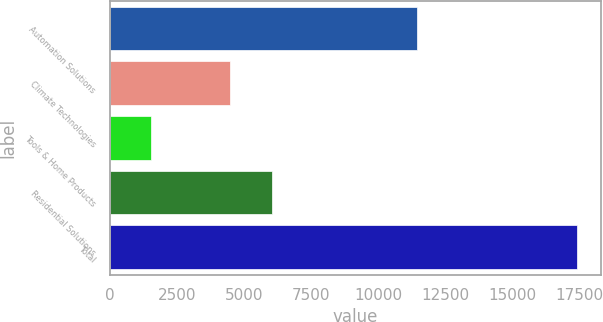<chart> <loc_0><loc_0><loc_500><loc_500><bar_chart><fcel>Automation Solutions<fcel>Climate Technologies<fcel>Tools & Home Products<fcel>Residential Solutions<fcel>Total<nl><fcel>11441<fcel>4454<fcel>1528<fcel>6042<fcel>17408<nl></chart> 